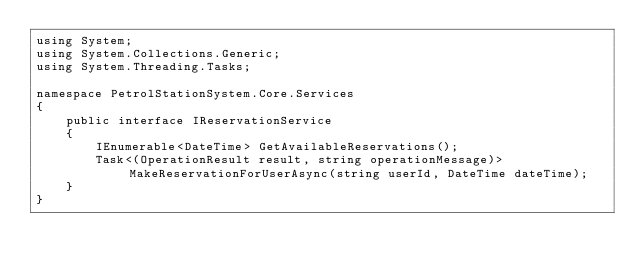Convert code to text. <code><loc_0><loc_0><loc_500><loc_500><_C#_>using System;
using System.Collections.Generic;
using System.Threading.Tasks;

namespace PetrolStationSystem.Core.Services
{
    public interface IReservationService
    {
        IEnumerable<DateTime> GetAvailableReservations();
        Task<(OperationResult result, string operationMessage)> MakeReservationForUserAsync(string userId, DateTime dateTime);
    }
}</code> 